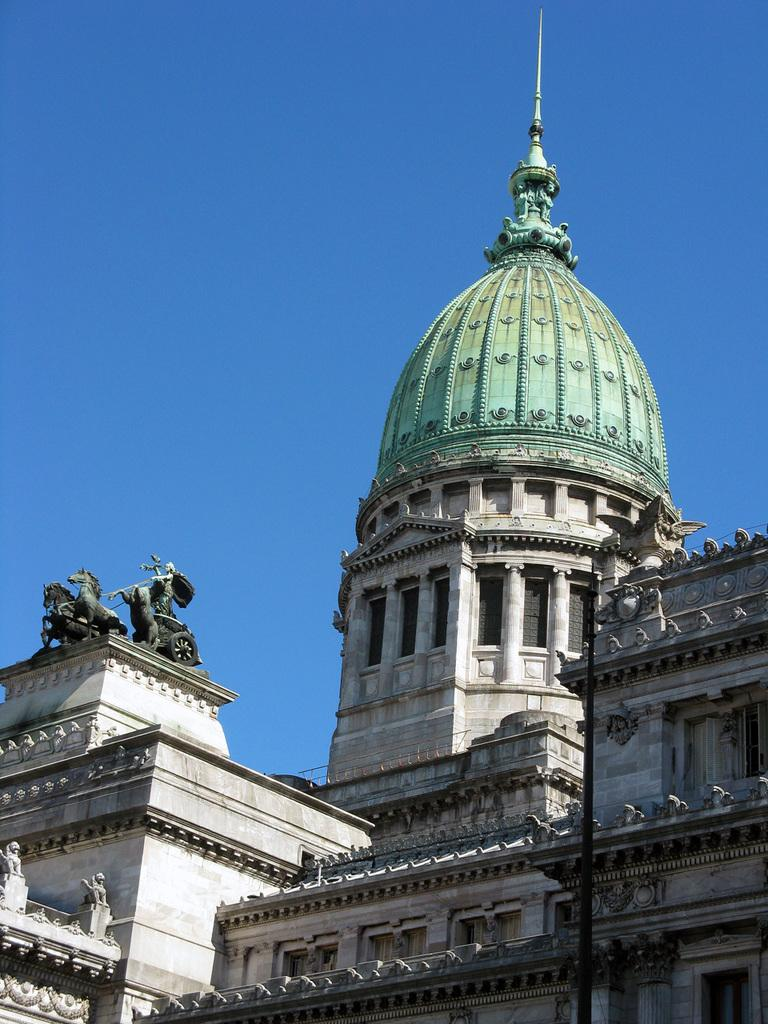What is the main subject of the picture? The main subject of the picture is a building. Are there any specific features on the building? Yes, the building has sculptures on it. What can be seen in the background of the picture? The sky is visible in the background of the picture. What type of floor can be seen in the building in the image? There is no information about the floor in the building, as the image only shows the exterior of the building with sculptures and the sky in the background. 